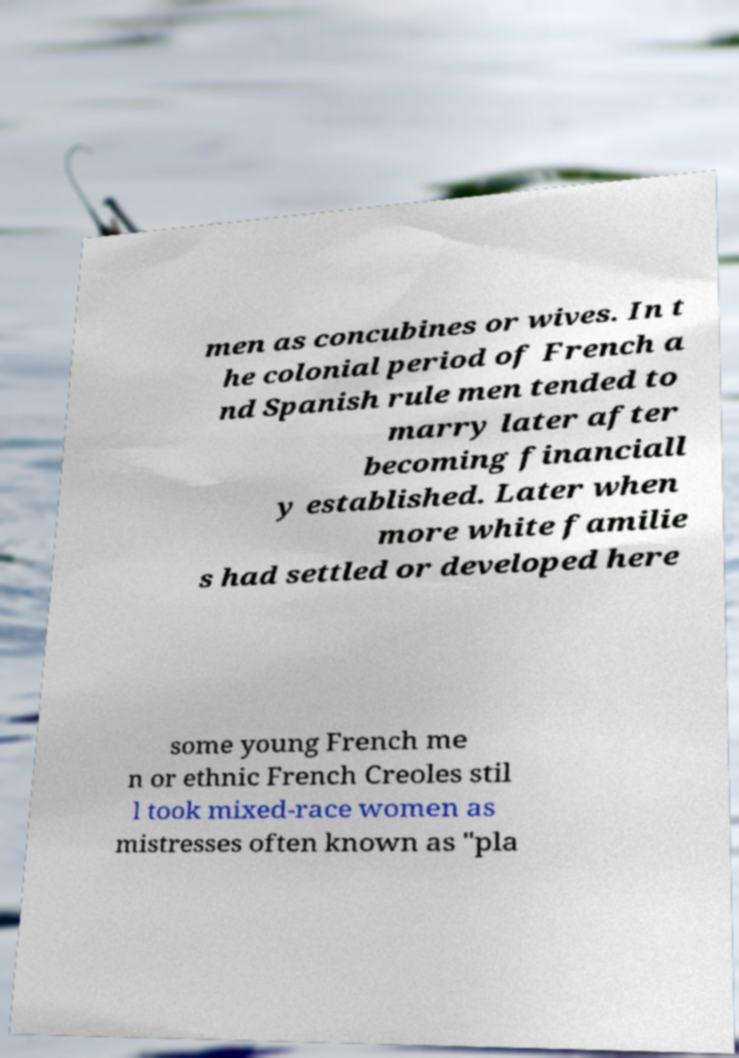Could you assist in decoding the text presented in this image and type it out clearly? men as concubines or wives. In t he colonial period of French a nd Spanish rule men tended to marry later after becoming financiall y established. Later when more white familie s had settled or developed here some young French me n or ethnic French Creoles stil l took mixed-race women as mistresses often known as "pla 